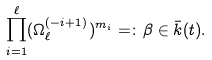Convert formula to latex. <formula><loc_0><loc_0><loc_500><loc_500>\prod _ { i = 1 } ^ { \ell } ( \Omega _ { \ell } ^ { ( - i + 1 ) } ) ^ { m _ { i } } = \colon \beta \in \bar { k } ( t ) .</formula> 